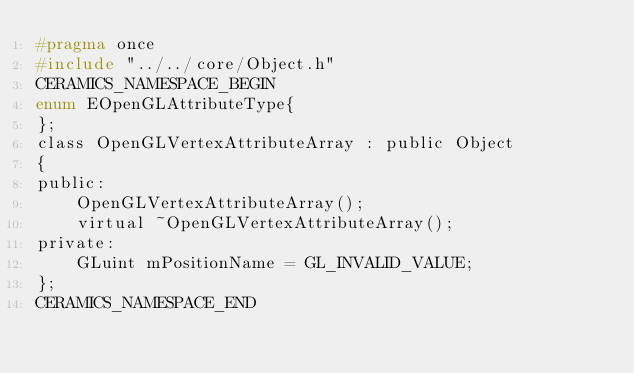<code> <loc_0><loc_0><loc_500><loc_500><_C_>#pragma once
#include "../../core/Object.h"
CERAMICS_NAMESPACE_BEGIN
enum EOpenGLAttributeType{
};
class OpenGLVertexAttributeArray : public Object
{
public:
    OpenGLVertexAttributeArray();
    virtual ~OpenGLVertexAttributeArray();
private:
    GLuint mPositionName = GL_INVALID_VALUE;
};
CERAMICS_NAMESPACE_END
</code> 